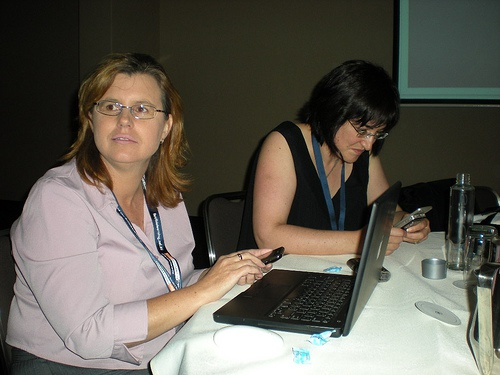Describe the objects in this image and their specific colors. I can see people in black, darkgray, and lightgray tones, dining table in black, ivory, darkgray, and gray tones, people in black, gray, and tan tones, laptop in black and gray tones, and keyboard in black and gray tones in this image. 